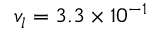<formula> <loc_0><loc_0><loc_500><loc_500>{ v _ { l } } 3 . 3 \times { 1 0 ^ { - 1 } }</formula> 